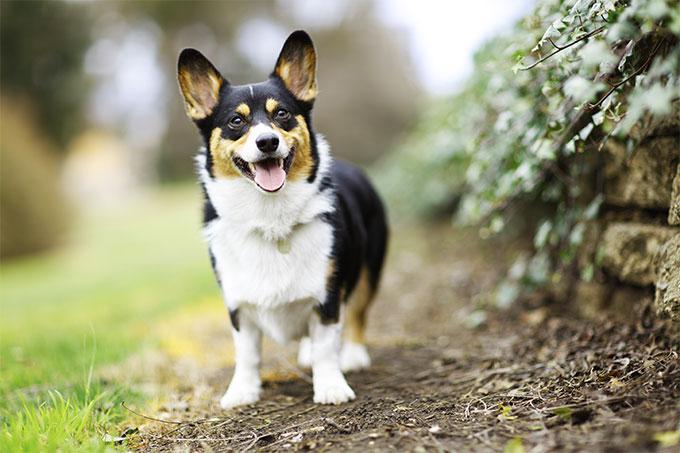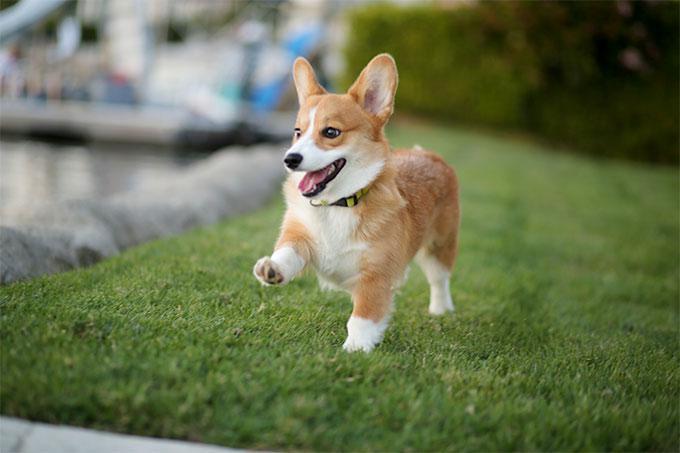The first image is the image on the left, the second image is the image on the right. Considering the images on both sides, is "At least one dog has some black fur." valid? Answer yes or no. Yes. The first image is the image on the left, the second image is the image on the right. Evaluate the accuracy of this statement regarding the images: "An image features a multi-colored dog with black markings that create a mask-look.". Is it true? Answer yes or no. Yes. 